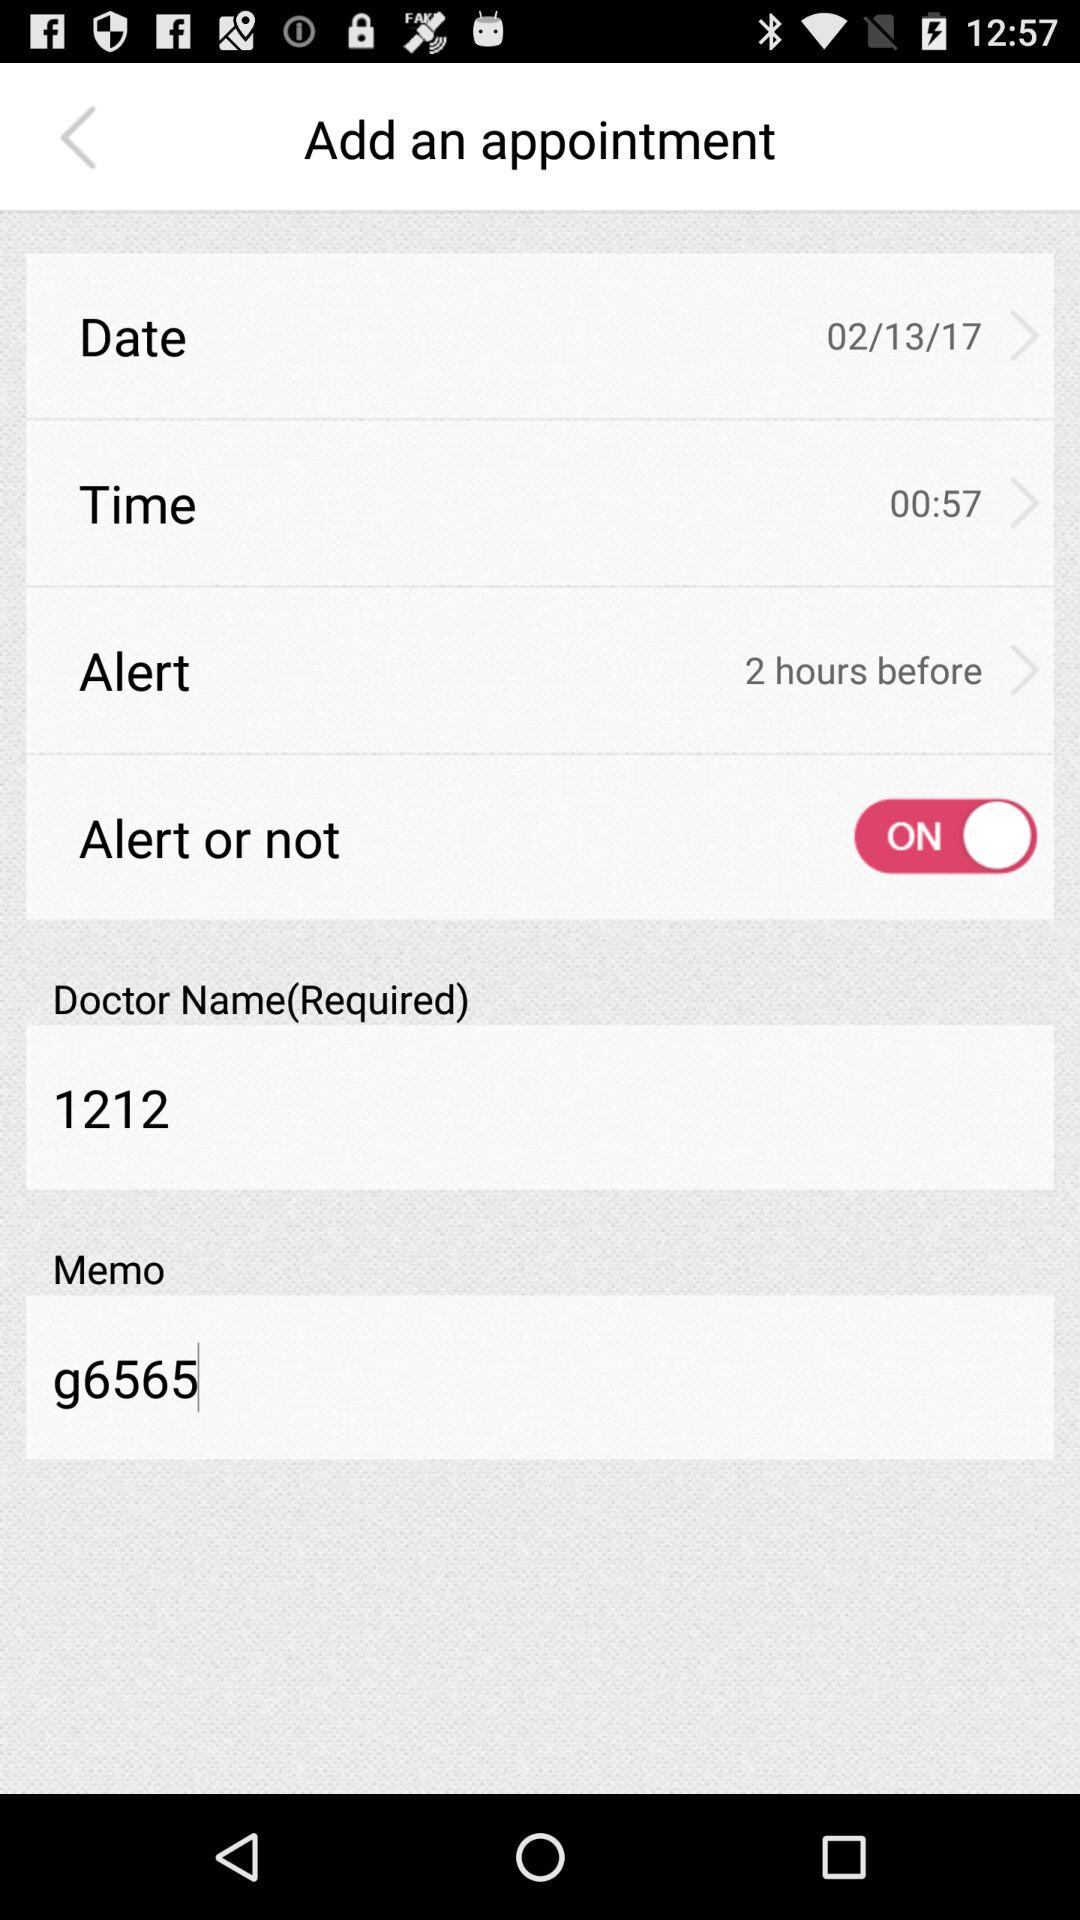What is the selected date? The selected date is February 13, 2017. 